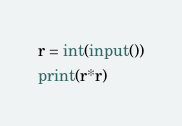<code> <loc_0><loc_0><loc_500><loc_500><_Python_>r = int(input())
print(r*r)</code> 